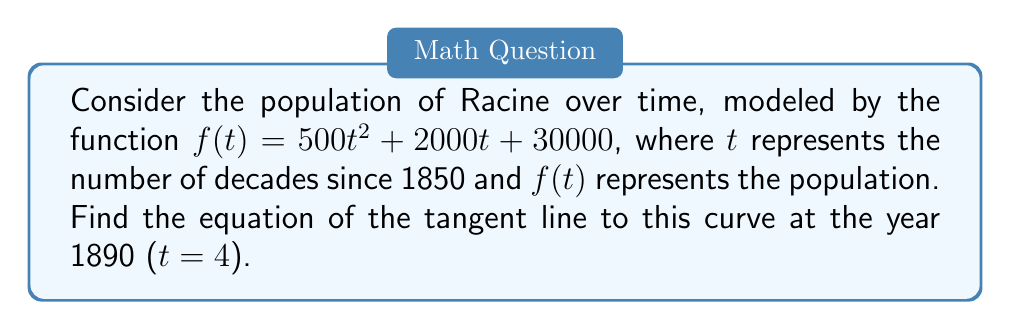What is the answer to this math problem? 1) First, we need to find the slope of the tangent line, which is the derivative of $f(t)$ at $t = 4$.

2) The derivative of $f(t)$ is:
   $f'(t) = 1000t + 2000$

3) At $t = 4$:
   $f'(4) = 1000(4) + 2000 = 6000$

4) Now we need to find the point on the curve at $t = 4$:
   $f(4) = 500(4^2) + 2000(4) + 30000$
         $= 500(16) + 8000 + 30000$
         $= 8000 + 8000 + 30000 = 46000$

5) So, the point is $(4, 46000)$

6) The equation of a tangent line is $y - y_1 = m(x - x_1)$, where $m$ is the slope and $(x_1, y_1)$ is the point of tangency.

7) Substituting our values:
   $y - 46000 = 6000(t - 4)$

8) Simplify:
   $y = 6000t - 24000 + 46000$
   $y = 6000t + 22000$

This is the equation of the tangent line.
Answer: $y = 6000t + 22000$ 